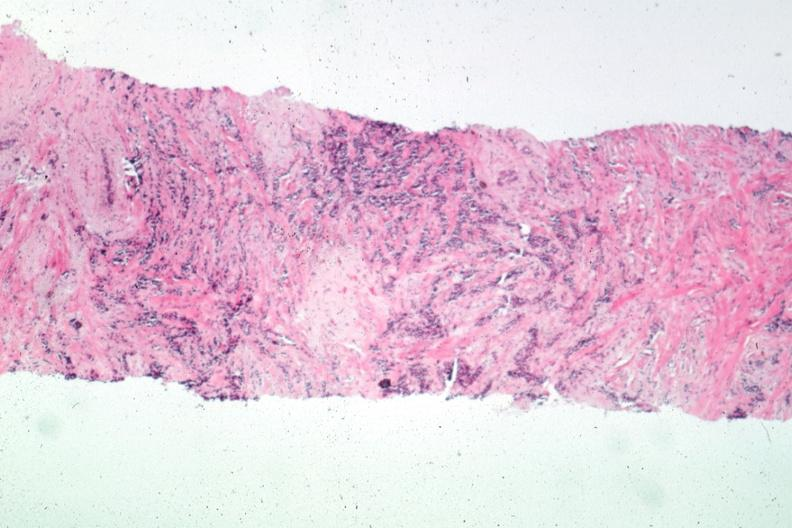how does this image show needle biopsy?
Answer the question using a single word or phrase. With obvious carcinoma 